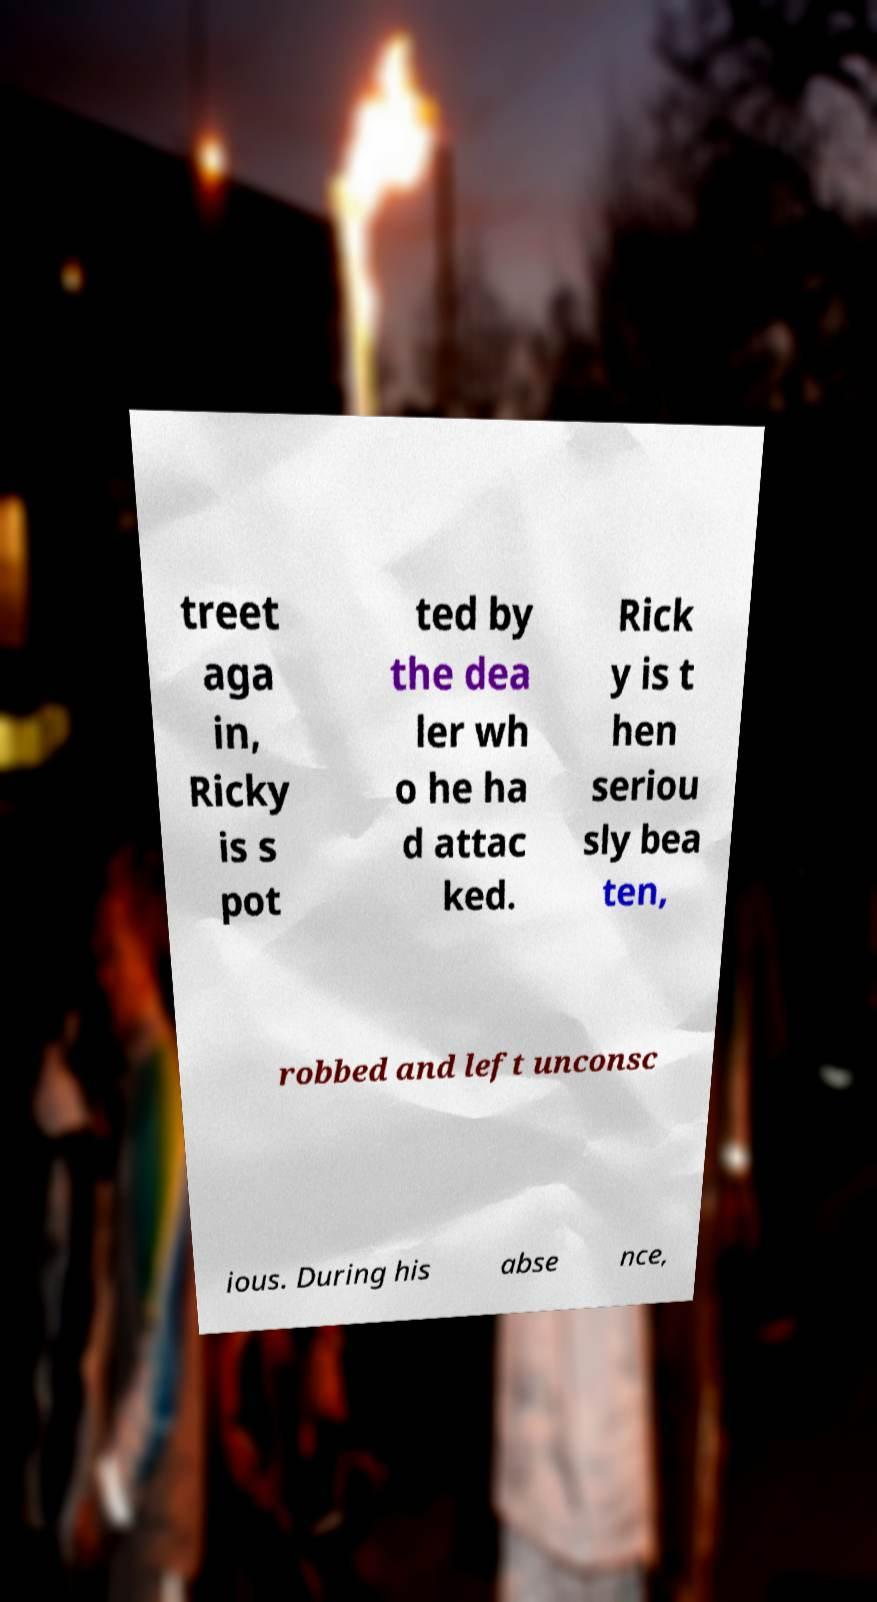For documentation purposes, I need the text within this image transcribed. Could you provide that? treet aga in, Ricky is s pot ted by the dea ler wh o he ha d attac ked. Rick y is t hen seriou sly bea ten, robbed and left unconsc ious. During his abse nce, 